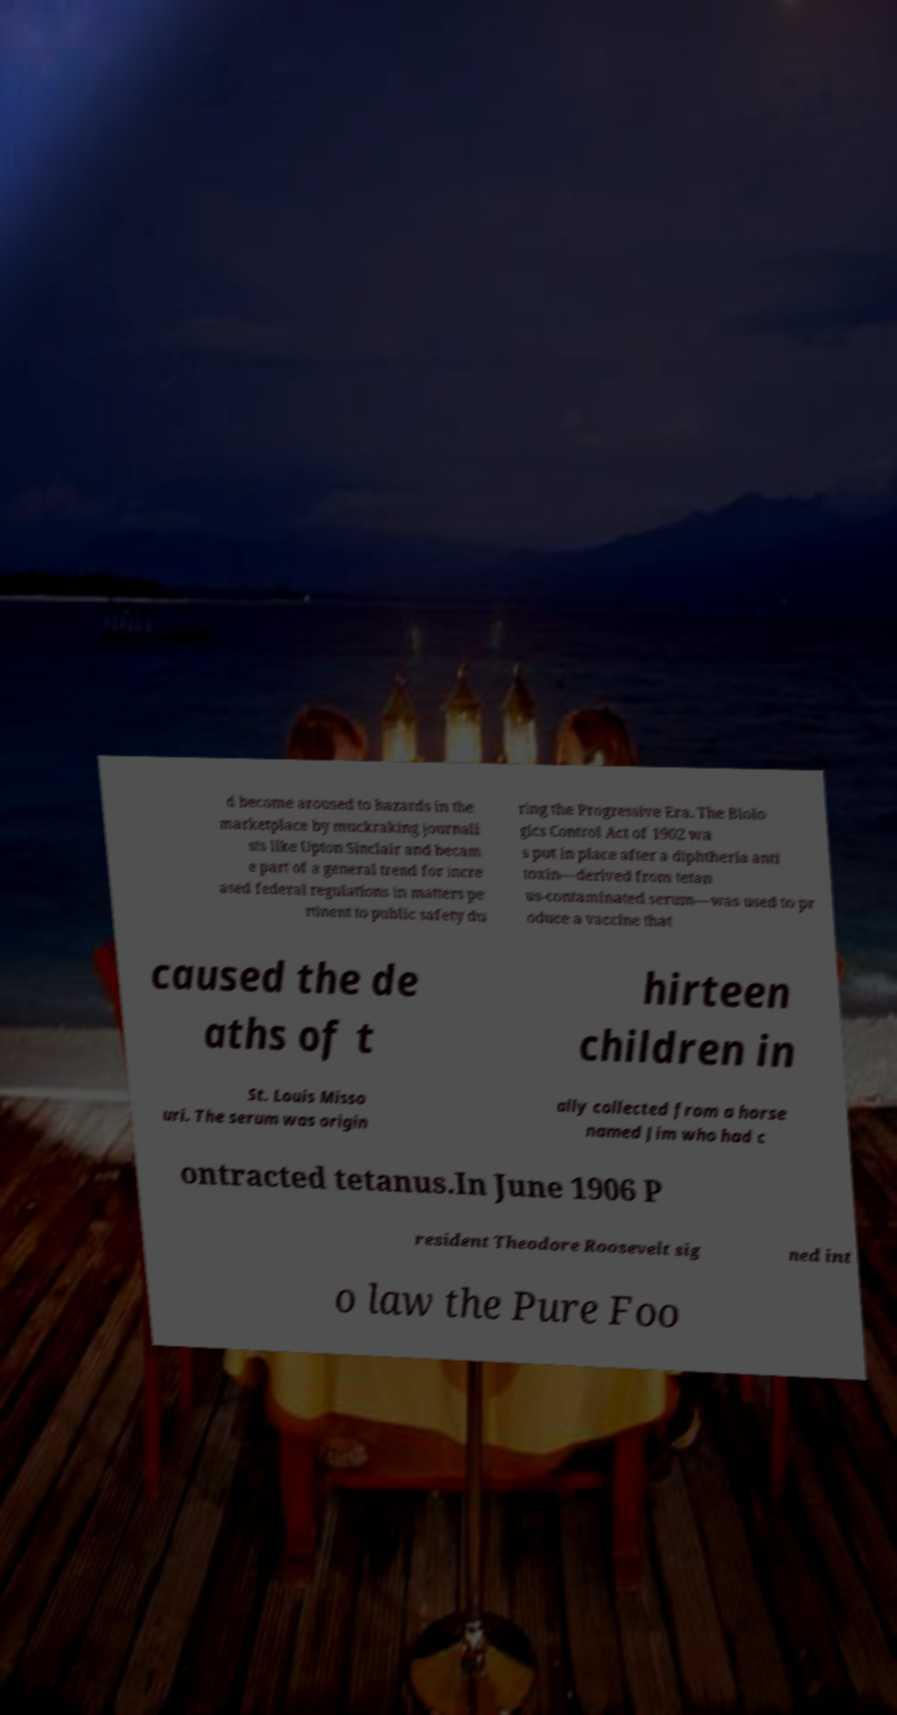Can you accurately transcribe the text from the provided image for me? d become aroused to hazards in the marketplace by muckraking journali sts like Upton Sinclair and becam e part of a general trend for incre ased federal regulations in matters pe rtinent to public safety du ring the Progressive Era. The Biolo gics Control Act of 1902 wa s put in place after a diphtheria anti toxin—derived from tetan us-contaminated serum—was used to pr oduce a vaccine that caused the de aths of t hirteen children in St. Louis Misso uri. The serum was origin ally collected from a horse named Jim who had c ontracted tetanus.In June 1906 P resident Theodore Roosevelt sig ned int o law the Pure Foo 